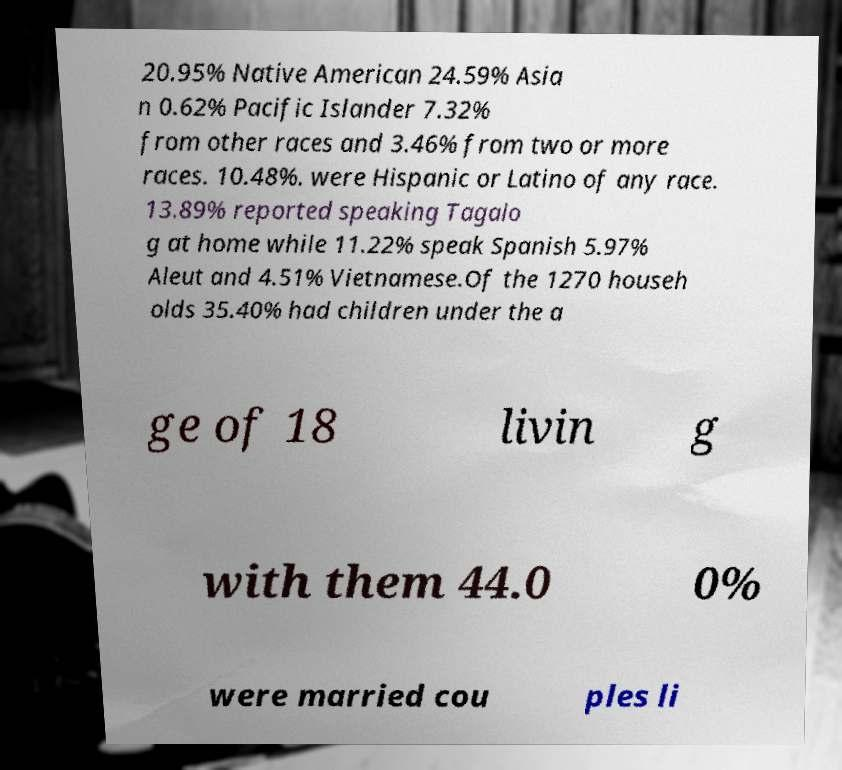I need the written content from this picture converted into text. Can you do that? 20.95% Native American 24.59% Asia n 0.62% Pacific Islander 7.32% from other races and 3.46% from two or more races. 10.48%. were Hispanic or Latino of any race. 13.89% reported speaking Tagalo g at home while 11.22% speak Spanish 5.97% Aleut and 4.51% Vietnamese.Of the 1270 househ olds 35.40% had children under the a ge of 18 livin g with them 44.0 0% were married cou ples li 